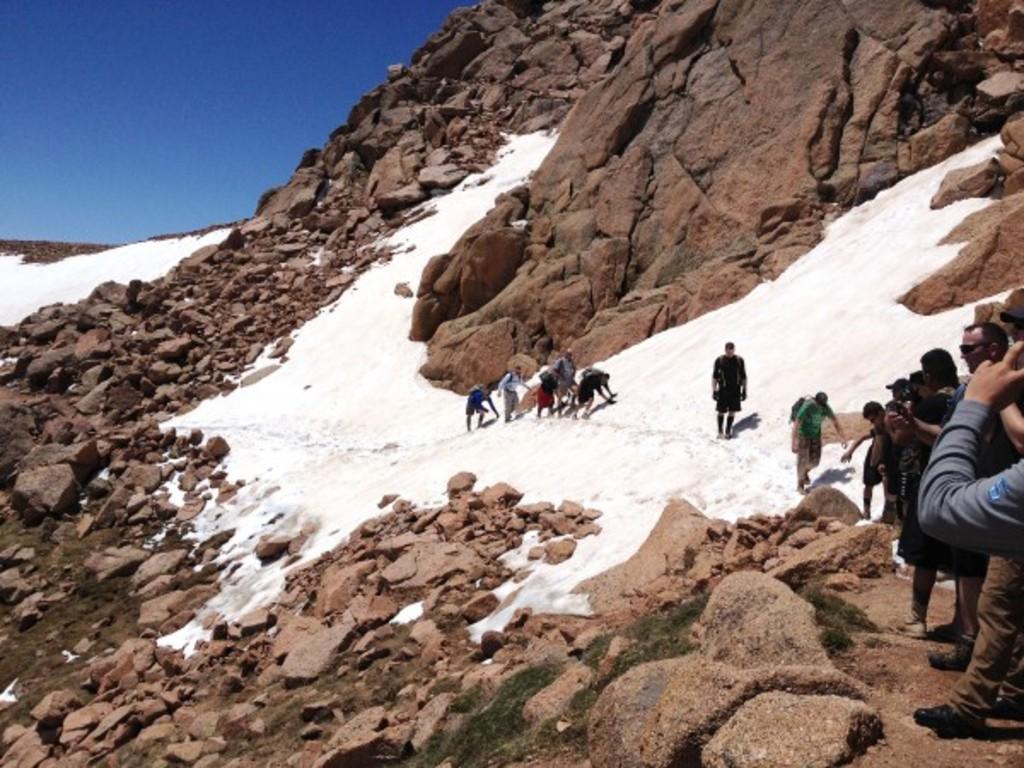Describe this image in one or two sentences. In this image we can see there are people standing and walking on the snow and holding cameras. And there are rocks and the sky. 